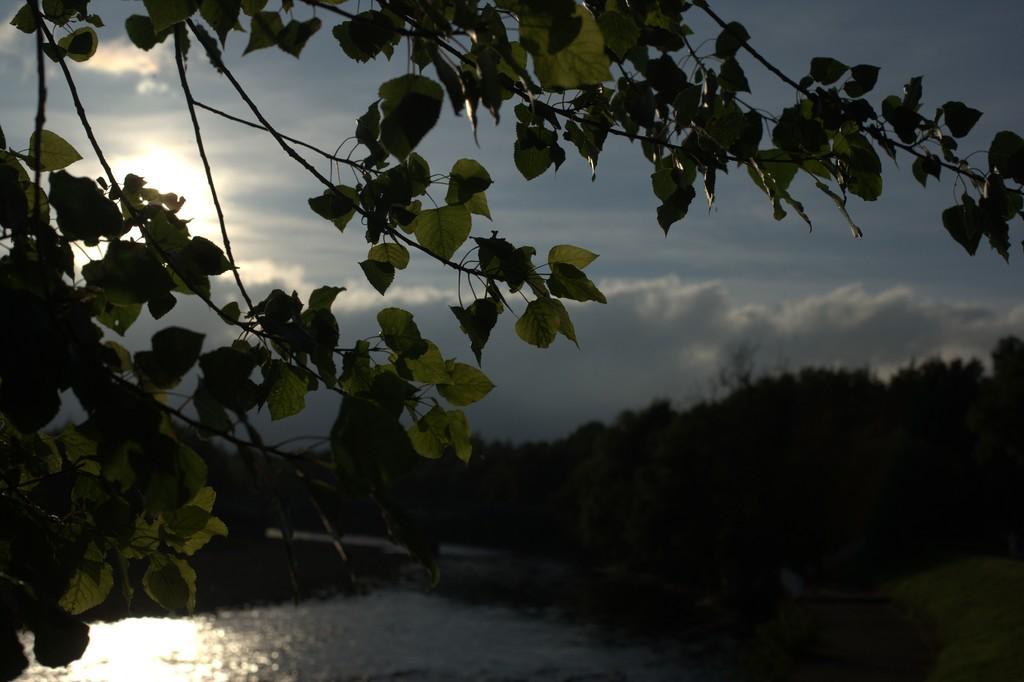How would you summarize this image in a sentence or two? In this image I can see few trees and water. The sky is in blue and white color. 